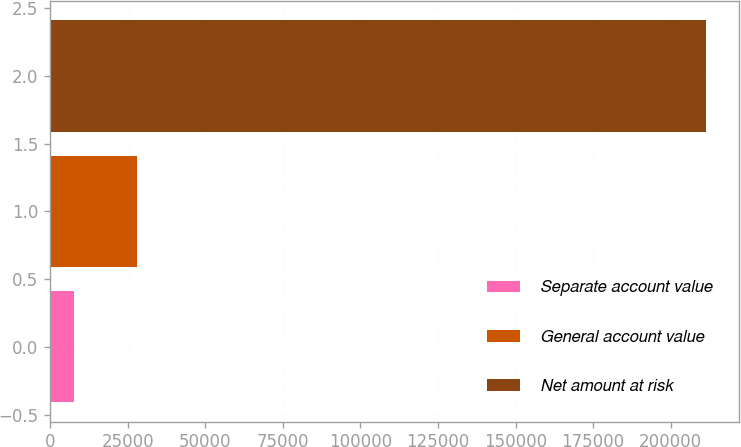Convert chart. <chart><loc_0><loc_0><loc_500><loc_500><bar_chart><fcel>Separate account value<fcel>General account value<fcel>Net amount at risk<nl><fcel>7643<fcel>28021.5<fcel>211428<nl></chart> 